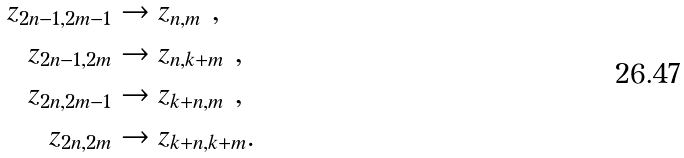Convert formula to latex. <formula><loc_0><loc_0><loc_500><loc_500>z _ { 2 n - 1 , 2 m - 1 } & \rightarrow z _ { n , m } \text { } , \\ z _ { 2 n - 1 , 2 m } & \rightarrow z _ { n , k + m } \text { } , \\ z _ { 2 n , 2 m - 1 } & \rightarrow z _ { k + n , m } \text { } , \\ z _ { 2 n , 2 m } & \rightarrow z _ { k + n , k + m } .</formula> 